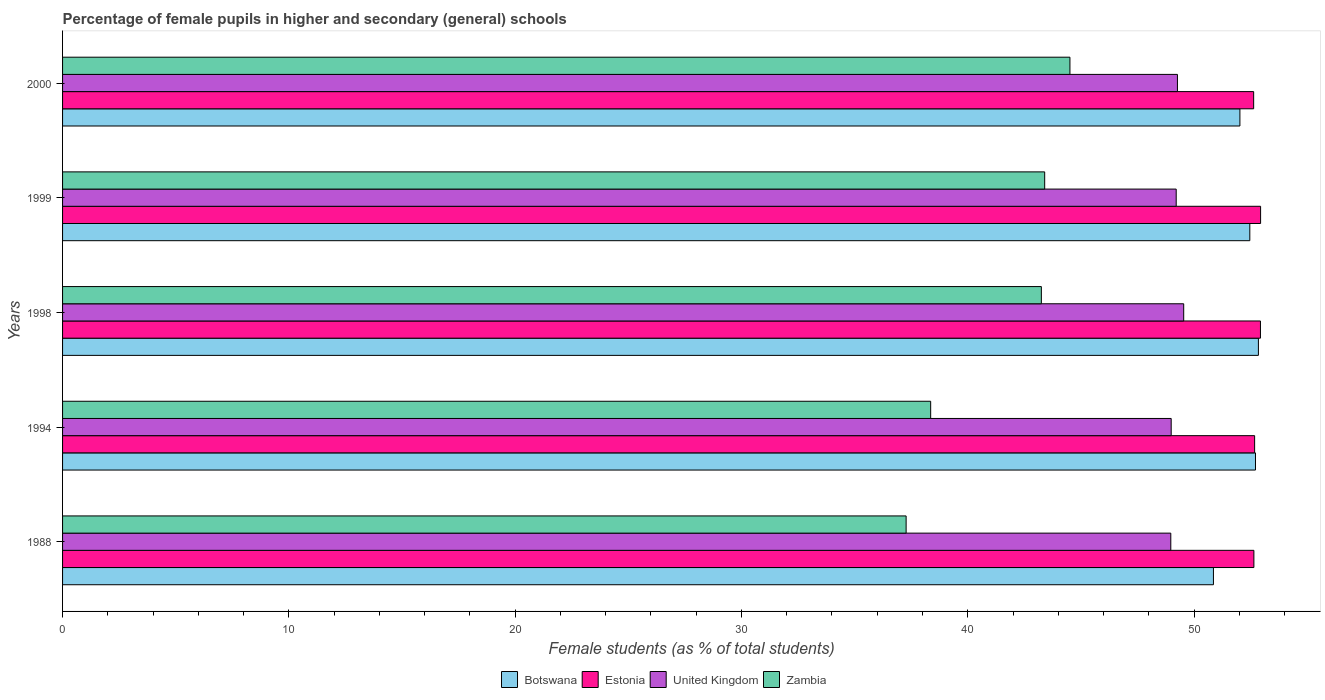What is the label of the 2nd group of bars from the top?
Provide a short and direct response. 1999. What is the percentage of female pupils in higher and secondary schools in Botswana in 1994?
Provide a short and direct response. 52.71. Across all years, what is the maximum percentage of female pupils in higher and secondary schools in Botswana?
Provide a succinct answer. 52.84. Across all years, what is the minimum percentage of female pupils in higher and secondary schools in Estonia?
Ensure brevity in your answer.  52.63. What is the total percentage of female pupils in higher and secondary schools in Zambia in the graph?
Offer a very short reply. 206.8. What is the difference between the percentage of female pupils in higher and secondary schools in Zambia in 1988 and that in 2000?
Ensure brevity in your answer.  -7.24. What is the difference between the percentage of female pupils in higher and secondary schools in Zambia in 1994 and the percentage of female pupils in higher and secondary schools in Estonia in 1998?
Offer a terse response. -14.57. What is the average percentage of female pupils in higher and secondary schools in Botswana per year?
Keep it short and to the point. 52.18. In the year 1988, what is the difference between the percentage of female pupils in higher and secondary schools in Zambia and percentage of female pupils in higher and secondary schools in Estonia?
Offer a terse response. -15.37. What is the ratio of the percentage of female pupils in higher and secondary schools in Botswana in 1994 to that in 2000?
Make the answer very short. 1.01. Is the difference between the percentage of female pupils in higher and secondary schools in Zambia in 1998 and 1999 greater than the difference between the percentage of female pupils in higher and secondary schools in Estonia in 1998 and 1999?
Your answer should be very brief. No. What is the difference between the highest and the second highest percentage of female pupils in higher and secondary schools in United Kingdom?
Keep it short and to the point. 0.28. What is the difference between the highest and the lowest percentage of female pupils in higher and secondary schools in Estonia?
Your answer should be compact. 0.31. What does the 4th bar from the bottom in 1999 represents?
Ensure brevity in your answer.  Zambia. Is it the case that in every year, the sum of the percentage of female pupils in higher and secondary schools in Estonia and percentage of female pupils in higher and secondary schools in Zambia is greater than the percentage of female pupils in higher and secondary schools in United Kingdom?
Offer a terse response. Yes. Are all the bars in the graph horizontal?
Your answer should be very brief. Yes. How many years are there in the graph?
Ensure brevity in your answer.  5. Are the values on the major ticks of X-axis written in scientific E-notation?
Your answer should be compact. No. Does the graph contain any zero values?
Ensure brevity in your answer.  No. Does the graph contain grids?
Provide a succinct answer. No. Where does the legend appear in the graph?
Ensure brevity in your answer.  Bottom center. How many legend labels are there?
Your response must be concise. 4. How are the legend labels stacked?
Your answer should be compact. Horizontal. What is the title of the graph?
Ensure brevity in your answer.  Percentage of female pupils in higher and secondary (general) schools. Does "Malaysia" appear as one of the legend labels in the graph?
Keep it short and to the point. No. What is the label or title of the X-axis?
Your answer should be compact. Female students (as % of total students). What is the Female students (as % of total students) of Botswana in 1988?
Ensure brevity in your answer.  50.86. What is the Female students (as % of total students) in Estonia in 1988?
Your answer should be very brief. 52.64. What is the Female students (as % of total students) in United Kingdom in 1988?
Ensure brevity in your answer.  48.97. What is the Female students (as % of total students) of Zambia in 1988?
Your answer should be very brief. 37.28. What is the Female students (as % of total students) in Botswana in 1994?
Your response must be concise. 52.71. What is the Female students (as % of total students) in Estonia in 1994?
Ensure brevity in your answer.  52.68. What is the Female students (as % of total students) in United Kingdom in 1994?
Provide a succinct answer. 48.99. What is the Female students (as % of total students) in Zambia in 1994?
Your answer should be very brief. 38.36. What is the Female students (as % of total students) of Botswana in 1998?
Keep it short and to the point. 52.84. What is the Female students (as % of total students) of Estonia in 1998?
Make the answer very short. 52.93. What is the Female students (as % of total students) in United Kingdom in 1998?
Provide a short and direct response. 49.54. What is the Female students (as % of total students) of Zambia in 1998?
Your answer should be very brief. 43.25. What is the Female students (as % of total students) in Botswana in 1999?
Give a very brief answer. 52.46. What is the Female students (as % of total students) of Estonia in 1999?
Offer a terse response. 52.94. What is the Female students (as % of total students) of United Kingdom in 1999?
Ensure brevity in your answer.  49.21. What is the Female students (as % of total students) in Zambia in 1999?
Provide a succinct answer. 43.4. What is the Female students (as % of total students) in Botswana in 2000?
Offer a terse response. 52.03. What is the Female students (as % of total students) of Estonia in 2000?
Make the answer very short. 52.63. What is the Female students (as % of total students) in United Kingdom in 2000?
Provide a succinct answer. 49.27. What is the Female students (as % of total students) of Zambia in 2000?
Make the answer very short. 44.52. Across all years, what is the maximum Female students (as % of total students) in Botswana?
Provide a succinct answer. 52.84. Across all years, what is the maximum Female students (as % of total students) of Estonia?
Keep it short and to the point. 52.94. Across all years, what is the maximum Female students (as % of total students) in United Kingdom?
Give a very brief answer. 49.54. Across all years, what is the maximum Female students (as % of total students) in Zambia?
Your response must be concise. 44.52. Across all years, what is the minimum Female students (as % of total students) in Botswana?
Keep it short and to the point. 50.86. Across all years, what is the minimum Female students (as % of total students) of Estonia?
Give a very brief answer. 52.63. Across all years, what is the minimum Female students (as % of total students) of United Kingdom?
Your response must be concise. 48.97. Across all years, what is the minimum Female students (as % of total students) of Zambia?
Make the answer very short. 37.28. What is the total Female students (as % of total students) of Botswana in the graph?
Make the answer very short. 260.9. What is the total Female students (as % of total students) of Estonia in the graph?
Make the answer very short. 263.83. What is the total Female students (as % of total students) of United Kingdom in the graph?
Provide a succinct answer. 245.98. What is the total Female students (as % of total students) in Zambia in the graph?
Keep it short and to the point. 206.8. What is the difference between the Female students (as % of total students) of Botswana in 1988 and that in 1994?
Make the answer very short. -1.86. What is the difference between the Female students (as % of total students) of Estonia in 1988 and that in 1994?
Offer a very short reply. -0.03. What is the difference between the Female students (as % of total students) in United Kingdom in 1988 and that in 1994?
Your answer should be compact. -0.02. What is the difference between the Female students (as % of total students) of Zambia in 1988 and that in 1994?
Offer a very short reply. -1.08. What is the difference between the Female students (as % of total students) in Botswana in 1988 and that in 1998?
Provide a succinct answer. -1.99. What is the difference between the Female students (as % of total students) of Estonia in 1988 and that in 1998?
Keep it short and to the point. -0.29. What is the difference between the Female students (as % of total students) of United Kingdom in 1988 and that in 1998?
Provide a succinct answer. -0.57. What is the difference between the Female students (as % of total students) in Zambia in 1988 and that in 1998?
Provide a succinct answer. -5.98. What is the difference between the Female students (as % of total students) in Botswana in 1988 and that in 1999?
Provide a short and direct response. -1.61. What is the difference between the Female students (as % of total students) of Estonia in 1988 and that in 1999?
Offer a terse response. -0.3. What is the difference between the Female students (as % of total students) in United Kingdom in 1988 and that in 1999?
Offer a terse response. -0.24. What is the difference between the Female students (as % of total students) in Zambia in 1988 and that in 1999?
Make the answer very short. -6.12. What is the difference between the Female students (as % of total students) of Botswana in 1988 and that in 2000?
Give a very brief answer. -1.17. What is the difference between the Female students (as % of total students) in Estonia in 1988 and that in 2000?
Keep it short and to the point. 0.01. What is the difference between the Female students (as % of total students) in United Kingdom in 1988 and that in 2000?
Offer a very short reply. -0.29. What is the difference between the Female students (as % of total students) in Zambia in 1988 and that in 2000?
Your response must be concise. -7.24. What is the difference between the Female students (as % of total students) of Botswana in 1994 and that in 1998?
Make the answer very short. -0.13. What is the difference between the Female students (as % of total students) in Estonia in 1994 and that in 1998?
Offer a very short reply. -0.26. What is the difference between the Female students (as % of total students) of United Kingdom in 1994 and that in 1998?
Provide a short and direct response. -0.55. What is the difference between the Female students (as % of total students) of Zambia in 1994 and that in 1998?
Your answer should be compact. -4.89. What is the difference between the Female students (as % of total students) in Botswana in 1994 and that in 1999?
Provide a short and direct response. 0.25. What is the difference between the Female students (as % of total students) of Estonia in 1994 and that in 1999?
Your response must be concise. -0.26. What is the difference between the Female students (as % of total students) in United Kingdom in 1994 and that in 1999?
Provide a succinct answer. -0.22. What is the difference between the Female students (as % of total students) in Zambia in 1994 and that in 1999?
Your answer should be very brief. -5.04. What is the difference between the Female students (as % of total students) of Botswana in 1994 and that in 2000?
Ensure brevity in your answer.  0.69. What is the difference between the Female students (as % of total students) of Estonia in 1994 and that in 2000?
Your answer should be compact. 0.04. What is the difference between the Female students (as % of total students) of United Kingdom in 1994 and that in 2000?
Keep it short and to the point. -0.28. What is the difference between the Female students (as % of total students) in Zambia in 1994 and that in 2000?
Your answer should be compact. -6.15. What is the difference between the Female students (as % of total students) of Botswana in 1998 and that in 1999?
Offer a terse response. 0.38. What is the difference between the Female students (as % of total students) in Estonia in 1998 and that in 1999?
Give a very brief answer. -0.01. What is the difference between the Female students (as % of total students) in United Kingdom in 1998 and that in 1999?
Ensure brevity in your answer.  0.33. What is the difference between the Female students (as % of total students) in Zambia in 1998 and that in 1999?
Offer a very short reply. -0.15. What is the difference between the Female students (as % of total students) in Botswana in 1998 and that in 2000?
Provide a short and direct response. 0.82. What is the difference between the Female students (as % of total students) in Estonia in 1998 and that in 2000?
Ensure brevity in your answer.  0.3. What is the difference between the Female students (as % of total students) of United Kingdom in 1998 and that in 2000?
Give a very brief answer. 0.28. What is the difference between the Female students (as % of total students) in Zambia in 1998 and that in 2000?
Make the answer very short. -1.26. What is the difference between the Female students (as % of total students) of Botswana in 1999 and that in 2000?
Give a very brief answer. 0.44. What is the difference between the Female students (as % of total students) in Estonia in 1999 and that in 2000?
Ensure brevity in your answer.  0.31. What is the difference between the Female students (as % of total students) in United Kingdom in 1999 and that in 2000?
Give a very brief answer. -0.05. What is the difference between the Female students (as % of total students) in Zambia in 1999 and that in 2000?
Keep it short and to the point. -1.12. What is the difference between the Female students (as % of total students) of Botswana in 1988 and the Female students (as % of total students) of Estonia in 1994?
Your answer should be very brief. -1.82. What is the difference between the Female students (as % of total students) in Botswana in 1988 and the Female students (as % of total students) in United Kingdom in 1994?
Your answer should be very brief. 1.87. What is the difference between the Female students (as % of total students) of Botswana in 1988 and the Female students (as % of total students) of Zambia in 1994?
Make the answer very short. 12.5. What is the difference between the Female students (as % of total students) in Estonia in 1988 and the Female students (as % of total students) in United Kingdom in 1994?
Give a very brief answer. 3.65. What is the difference between the Female students (as % of total students) in Estonia in 1988 and the Female students (as % of total students) in Zambia in 1994?
Give a very brief answer. 14.28. What is the difference between the Female students (as % of total students) in United Kingdom in 1988 and the Female students (as % of total students) in Zambia in 1994?
Make the answer very short. 10.61. What is the difference between the Female students (as % of total students) in Botswana in 1988 and the Female students (as % of total students) in Estonia in 1998?
Your response must be concise. -2.08. What is the difference between the Female students (as % of total students) in Botswana in 1988 and the Female students (as % of total students) in United Kingdom in 1998?
Your response must be concise. 1.31. What is the difference between the Female students (as % of total students) of Botswana in 1988 and the Female students (as % of total students) of Zambia in 1998?
Provide a succinct answer. 7.6. What is the difference between the Female students (as % of total students) of Estonia in 1988 and the Female students (as % of total students) of United Kingdom in 1998?
Provide a short and direct response. 3.1. What is the difference between the Female students (as % of total students) of Estonia in 1988 and the Female students (as % of total students) of Zambia in 1998?
Offer a terse response. 9.39. What is the difference between the Female students (as % of total students) in United Kingdom in 1988 and the Female students (as % of total students) in Zambia in 1998?
Provide a succinct answer. 5.72. What is the difference between the Female students (as % of total students) in Botswana in 1988 and the Female students (as % of total students) in Estonia in 1999?
Provide a short and direct response. -2.08. What is the difference between the Female students (as % of total students) in Botswana in 1988 and the Female students (as % of total students) in United Kingdom in 1999?
Provide a short and direct response. 1.65. What is the difference between the Female students (as % of total students) in Botswana in 1988 and the Female students (as % of total students) in Zambia in 1999?
Your answer should be very brief. 7.46. What is the difference between the Female students (as % of total students) in Estonia in 1988 and the Female students (as % of total students) in United Kingdom in 1999?
Ensure brevity in your answer.  3.43. What is the difference between the Female students (as % of total students) of Estonia in 1988 and the Female students (as % of total students) of Zambia in 1999?
Offer a terse response. 9.24. What is the difference between the Female students (as % of total students) in United Kingdom in 1988 and the Female students (as % of total students) in Zambia in 1999?
Your response must be concise. 5.57. What is the difference between the Female students (as % of total students) of Botswana in 1988 and the Female students (as % of total students) of Estonia in 2000?
Your response must be concise. -1.78. What is the difference between the Female students (as % of total students) in Botswana in 1988 and the Female students (as % of total students) in United Kingdom in 2000?
Your answer should be compact. 1.59. What is the difference between the Female students (as % of total students) in Botswana in 1988 and the Female students (as % of total students) in Zambia in 2000?
Keep it short and to the point. 6.34. What is the difference between the Female students (as % of total students) in Estonia in 1988 and the Female students (as % of total students) in United Kingdom in 2000?
Provide a succinct answer. 3.38. What is the difference between the Female students (as % of total students) in Estonia in 1988 and the Female students (as % of total students) in Zambia in 2000?
Offer a very short reply. 8.13. What is the difference between the Female students (as % of total students) of United Kingdom in 1988 and the Female students (as % of total students) of Zambia in 2000?
Make the answer very short. 4.46. What is the difference between the Female students (as % of total students) of Botswana in 1994 and the Female students (as % of total students) of Estonia in 1998?
Your response must be concise. -0.22. What is the difference between the Female students (as % of total students) of Botswana in 1994 and the Female students (as % of total students) of United Kingdom in 1998?
Ensure brevity in your answer.  3.17. What is the difference between the Female students (as % of total students) of Botswana in 1994 and the Female students (as % of total students) of Zambia in 1998?
Ensure brevity in your answer.  9.46. What is the difference between the Female students (as % of total students) of Estonia in 1994 and the Female students (as % of total students) of United Kingdom in 1998?
Offer a terse response. 3.13. What is the difference between the Female students (as % of total students) of Estonia in 1994 and the Female students (as % of total students) of Zambia in 1998?
Provide a succinct answer. 9.42. What is the difference between the Female students (as % of total students) of United Kingdom in 1994 and the Female students (as % of total students) of Zambia in 1998?
Offer a terse response. 5.74. What is the difference between the Female students (as % of total students) in Botswana in 1994 and the Female students (as % of total students) in Estonia in 1999?
Keep it short and to the point. -0.23. What is the difference between the Female students (as % of total students) of Botswana in 1994 and the Female students (as % of total students) of United Kingdom in 1999?
Provide a short and direct response. 3.5. What is the difference between the Female students (as % of total students) of Botswana in 1994 and the Female students (as % of total students) of Zambia in 1999?
Your answer should be very brief. 9.31. What is the difference between the Female students (as % of total students) in Estonia in 1994 and the Female students (as % of total students) in United Kingdom in 1999?
Give a very brief answer. 3.47. What is the difference between the Female students (as % of total students) of Estonia in 1994 and the Female students (as % of total students) of Zambia in 1999?
Provide a short and direct response. 9.28. What is the difference between the Female students (as % of total students) of United Kingdom in 1994 and the Female students (as % of total students) of Zambia in 1999?
Offer a terse response. 5.59. What is the difference between the Female students (as % of total students) in Botswana in 1994 and the Female students (as % of total students) in Estonia in 2000?
Make the answer very short. 0.08. What is the difference between the Female students (as % of total students) in Botswana in 1994 and the Female students (as % of total students) in United Kingdom in 2000?
Make the answer very short. 3.45. What is the difference between the Female students (as % of total students) in Botswana in 1994 and the Female students (as % of total students) in Zambia in 2000?
Offer a terse response. 8.2. What is the difference between the Female students (as % of total students) in Estonia in 1994 and the Female students (as % of total students) in United Kingdom in 2000?
Offer a terse response. 3.41. What is the difference between the Female students (as % of total students) of Estonia in 1994 and the Female students (as % of total students) of Zambia in 2000?
Keep it short and to the point. 8.16. What is the difference between the Female students (as % of total students) in United Kingdom in 1994 and the Female students (as % of total students) in Zambia in 2000?
Your response must be concise. 4.47. What is the difference between the Female students (as % of total students) of Botswana in 1998 and the Female students (as % of total students) of Estonia in 1999?
Keep it short and to the point. -0.1. What is the difference between the Female students (as % of total students) in Botswana in 1998 and the Female students (as % of total students) in United Kingdom in 1999?
Keep it short and to the point. 3.63. What is the difference between the Female students (as % of total students) in Botswana in 1998 and the Female students (as % of total students) in Zambia in 1999?
Give a very brief answer. 9.44. What is the difference between the Female students (as % of total students) of Estonia in 1998 and the Female students (as % of total students) of United Kingdom in 1999?
Give a very brief answer. 3.72. What is the difference between the Female students (as % of total students) of Estonia in 1998 and the Female students (as % of total students) of Zambia in 1999?
Offer a terse response. 9.53. What is the difference between the Female students (as % of total students) in United Kingdom in 1998 and the Female students (as % of total students) in Zambia in 1999?
Keep it short and to the point. 6.14. What is the difference between the Female students (as % of total students) in Botswana in 1998 and the Female students (as % of total students) in Estonia in 2000?
Your answer should be very brief. 0.21. What is the difference between the Female students (as % of total students) in Botswana in 1998 and the Female students (as % of total students) in United Kingdom in 2000?
Your response must be concise. 3.58. What is the difference between the Female students (as % of total students) in Botswana in 1998 and the Female students (as % of total students) in Zambia in 2000?
Your answer should be very brief. 8.33. What is the difference between the Female students (as % of total students) of Estonia in 1998 and the Female students (as % of total students) of United Kingdom in 2000?
Your answer should be very brief. 3.67. What is the difference between the Female students (as % of total students) in Estonia in 1998 and the Female students (as % of total students) in Zambia in 2000?
Your answer should be compact. 8.42. What is the difference between the Female students (as % of total students) in United Kingdom in 1998 and the Female students (as % of total students) in Zambia in 2000?
Your response must be concise. 5.03. What is the difference between the Female students (as % of total students) in Botswana in 1999 and the Female students (as % of total students) in Estonia in 2000?
Provide a short and direct response. -0.17. What is the difference between the Female students (as % of total students) in Botswana in 1999 and the Female students (as % of total students) in United Kingdom in 2000?
Your answer should be compact. 3.2. What is the difference between the Female students (as % of total students) in Botswana in 1999 and the Female students (as % of total students) in Zambia in 2000?
Provide a succinct answer. 7.95. What is the difference between the Female students (as % of total students) of Estonia in 1999 and the Female students (as % of total students) of United Kingdom in 2000?
Your answer should be very brief. 3.67. What is the difference between the Female students (as % of total students) of Estonia in 1999 and the Female students (as % of total students) of Zambia in 2000?
Make the answer very short. 8.42. What is the difference between the Female students (as % of total students) of United Kingdom in 1999 and the Female students (as % of total students) of Zambia in 2000?
Your answer should be compact. 4.7. What is the average Female students (as % of total students) in Botswana per year?
Give a very brief answer. 52.18. What is the average Female students (as % of total students) in Estonia per year?
Your response must be concise. 52.77. What is the average Female students (as % of total students) of United Kingdom per year?
Your answer should be compact. 49.2. What is the average Female students (as % of total students) of Zambia per year?
Offer a terse response. 41.36. In the year 1988, what is the difference between the Female students (as % of total students) in Botswana and Female students (as % of total students) in Estonia?
Your answer should be very brief. -1.79. In the year 1988, what is the difference between the Female students (as % of total students) of Botswana and Female students (as % of total students) of United Kingdom?
Make the answer very short. 1.88. In the year 1988, what is the difference between the Female students (as % of total students) of Botswana and Female students (as % of total students) of Zambia?
Make the answer very short. 13.58. In the year 1988, what is the difference between the Female students (as % of total students) in Estonia and Female students (as % of total students) in United Kingdom?
Your answer should be compact. 3.67. In the year 1988, what is the difference between the Female students (as % of total students) of Estonia and Female students (as % of total students) of Zambia?
Offer a terse response. 15.37. In the year 1988, what is the difference between the Female students (as % of total students) of United Kingdom and Female students (as % of total students) of Zambia?
Provide a short and direct response. 11.7. In the year 1994, what is the difference between the Female students (as % of total students) in Botswana and Female students (as % of total students) in Estonia?
Offer a terse response. 0.04. In the year 1994, what is the difference between the Female students (as % of total students) of Botswana and Female students (as % of total students) of United Kingdom?
Offer a very short reply. 3.73. In the year 1994, what is the difference between the Female students (as % of total students) of Botswana and Female students (as % of total students) of Zambia?
Provide a succinct answer. 14.35. In the year 1994, what is the difference between the Female students (as % of total students) in Estonia and Female students (as % of total students) in United Kingdom?
Offer a terse response. 3.69. In the year 1994, what is the difference between the Female students (as % of total students) in Estonia and Female students (as % of total students) in Zambia?
Your response must be concise. 14.32. In the year 1994, what is the difference between the Female students (as % of total students) of United Kingdom and Female students (as % of total students) of Zambia?
Provide a succinct answer. 10.63. In the year 1998, what is the difference between the Female students (as % of total students) of Botswana and Female students (as % of total students) of Estonia?
Provide a short and direct response. -0.09. In the year 1998, what is the difference between the Female students (as % of total students) of Botswana and Female students (as % of total students) of United Kingdom?
Make the answer very short. 3.3. In the year 1998, what is the difference between the Female students (as % of total students) in Botswana and Female students (as % of total students) in Zambia?
Keep it short and to the point. 9.59. In the year 1998, what is the difference between the Female students (as % of total students) of Estonia and Female students (as % of total students) of United Kingdom?
Ensure brevity in your answer.  3.39. In the year 1998, what is the difference between the Female students (as % of total students) of Estonia and Female students (as % of total students) of Zambia?
Your response must be concise. 9.68. In the year 1998, what is the difference between the Female students (as % of total students) of United Kingdom and Female students (as % of total students) of Zambia?
Offer a terse response. 6.29. In the year 1999, what is the difference between the Female students (as % of total students) in Botswana and Female students (as % of total students) in Estonia?
Offer a very short reply. -0.48. In the year 1999, what is the difference between the Female students (as % of total students) in Botswana and Female students (as % of total students) in United Kingdom?
Your answer should be very brief. 3.25. In the year 1999, what is the difference between the Female students (as % of total students) in Botswana and Female students (as % of total students) in Zambia?
Provide a short and direct response. 9.06. In the year 1999, what is the difference between the Female students (as % of total students) in Estonia and Female students (as % of total students) in United Kingdom?
Your response must be concise. 3.73. In the year 1999, what is the difference between the Female students (as % of total students) of Estonia and Female students (as % of total students) of Zambia?
Provide a short and direct response. 9.54. In the year 1999, what is the difference between the Female students (as % of total students) in United Kingdom and Female students (as % of total students) in Zambia?
Your answer should be compact. 5.81. In the year 2000, what is the difference between the Female students (as % of total students) of Botswana and Female students (as % of total students) of Estonia?
Provide a short and direct response. -0.61. In the year 2000, what is the difference between the Female students (as % of total students) of Botswana and Female students (as % of total students) of United Kingdom?
Ensure brevity in your answer.  2.76. In the year 2000, what is the difference between the Female students (as % of total students) in Botswana and Female students (as % of total students) in Zambia?
Offer a very short reply. 7.51. In the year 2000, what is the difference between the Female students (as % of total students) of Estonia and Female students (as % of total students) of United Kingdom?
Make the answer very short. 3.37. In the year 2000, what is the difference between the Female students (as % of total students) in Estonia and Female students (as % of total students) in Zambia?
Ensure brevity in your answer.  8.12. In the year 2000, what is the difference between the Female students (as % of total students) in United Kingdom and Female students (as % of total students) in Zambia?
Offer a very short reply. 4.75. What is the ratio of the Female students (as % of total students) in Botswana in 1988 to that in 1994?
Give a very brief answer. 0.96. What is the ratio of the Female students (as % of total students) of United Kingdom in 1988 to that in 1994?
Make the answer very short. 1. What is the ratio of the Female students (as % of total students) in Zambia in 1988 to that in 1994?
Your answer should be compact. 0.97. What is the ratio of the Female students (as % of total students) in Botswana in 1988 to that in 1998?
Ensure brevity in your answer.  0.96. What is the ratio of the Female students (as % of total students) in Estonia in 1988 to that in 1998?
Your answer should be very brief. 0.99. What is the ratio of the Female students (as % of total students) in United Kingdom in 1988 to that in 1998?
Offer a very short reply. 0.99. What is the ratio of the Female students (as % of total students) of Zambia in 1988 to that in 1998?
Keep it short and to the point. 0.86. What is the ratio of the Female students (as % of total students) in Botswana in 1988 to that in 1999?
Provide a succinct answer. 0.97. What is the ratio of the Female students (as % of total students) of Estonia in 1988 to that in 1999?
Ensure brevity in your answer.  0.99. What is the ratio of the Female students (as % of total students) of United Kingdom in 1988 to that in 1999?
Your response must be concise. 1. What is the ratio of the Female students (as % of total students) of Zambia in 1988 to that in 1999?
Your response must be concise. 0.86. What is the ratio of the Female students (as % of total students) in Botswana in 1988 to that in 2000?
Ensure brevity in your answer.  0.98. What is the ratio of the Female students (as % of total students) in Estonia in 1988 to that in 2000?
Provide a short and direct response. 1. What is the ratio of the Female students (as % of total students) of United Kingdom in 1988 to that in 2000?
Provide a succinct answer. 0.99. What is the ratio of the Female students (as % of total students) in Zambia in 1988 to that in 2000?
Offer a terse response. 0.84. What is the ratio of the Female students (as % of total students) in United Kingdom in 1994 to that in 1998?
Your answer should be compact. 0.99. What is the ratio of the Female students (as % of total students) of Zambia in 1994 to that in 1998?
Ensure brevity in your answer.  0.89. What is the ratio of the Female students (as % of total students) in Zambia in 1994 to that in 1999?
Your answer should be very brief. 0.88. What is the ratio of the Female students (as % of total students) in Botswana in 1994 to that in 2000?
Your answer should be very brief. 1.01. What is the ratio of the Female students (as % of total students) of Estonia in 1994 to that in 2000?
Offer a terse response. 1. What is the ratio of the Female students (as % of total students) of Zambia in 1994 to that in 2000?
Provide a succinct answer. 0.86. What is the ratio of the Female students (as % of total students) of Botswana in 1998 to that in 1999?
Provide a short and direct response. 1.01. What is the ratio of the Female students (as % of total students) in United Kingdom in 1998 to that in 1999?
Keep it short and to the point. 1.01. What is the ratio of the Female students (as % of total students) in Botswana in 1998 to that in 2000?
Give a very brief answer. 1.02. What is the ratio of the Female students (as % of total students) in United Kingdom in 1998 to that in 2000?
Ensure brevity in your answer.  1.01. What is the ratio of the Female students (as % of total students) of Zambia in 1998 to that in 2000?
Offer a terse response. 0.97. What is the ratio of the Female students (as % of total students) in Botswana in 1999 to that in 2000?
Offer a very short reply. 1.01. What is the ratio of the Female students (as % of total students) in United Kingdom in 1999 to that in 2000?
Provide a succinct answer. 1. What is the ratio of the Female students (as % of total students) in Zambia in 1999 to that in 2000?
Make the answer very short. 0.97. What is the difference between the highest and the second highest Female students (as % of total students) in Botswana?
Provide a short and direct response. 0.13. What is the difference between the highest and the second highest Female students (as % of total students) in Estonia?
Ensure brevity in your answer.  0.01. What is the difference between the highest and the second highest Female students (as % of total students) in United Kingdom?
Keep it short and to the point. 0.28. What is the difference between the highest and the second highest Female students (as % of total students) of Zambia?
Provide a succinct answer. 1.12. What is the difference between the highest and the lowest Female students (as % of total students) of Botswana?
Offer a terse response. 1.99. What is the difference between the highest and the lowest Female students (as % of total students) of Estonia?
Offer a very short reply. 0.31. What is the difference between the highest and the lowest Female students (as % of total students) of United Kingdom?
Make the answer very short. 0.57. What is the difference between the highest and the lowest Female students (as % of total students) in Zambia?
Offer a terse response. 7.24. 